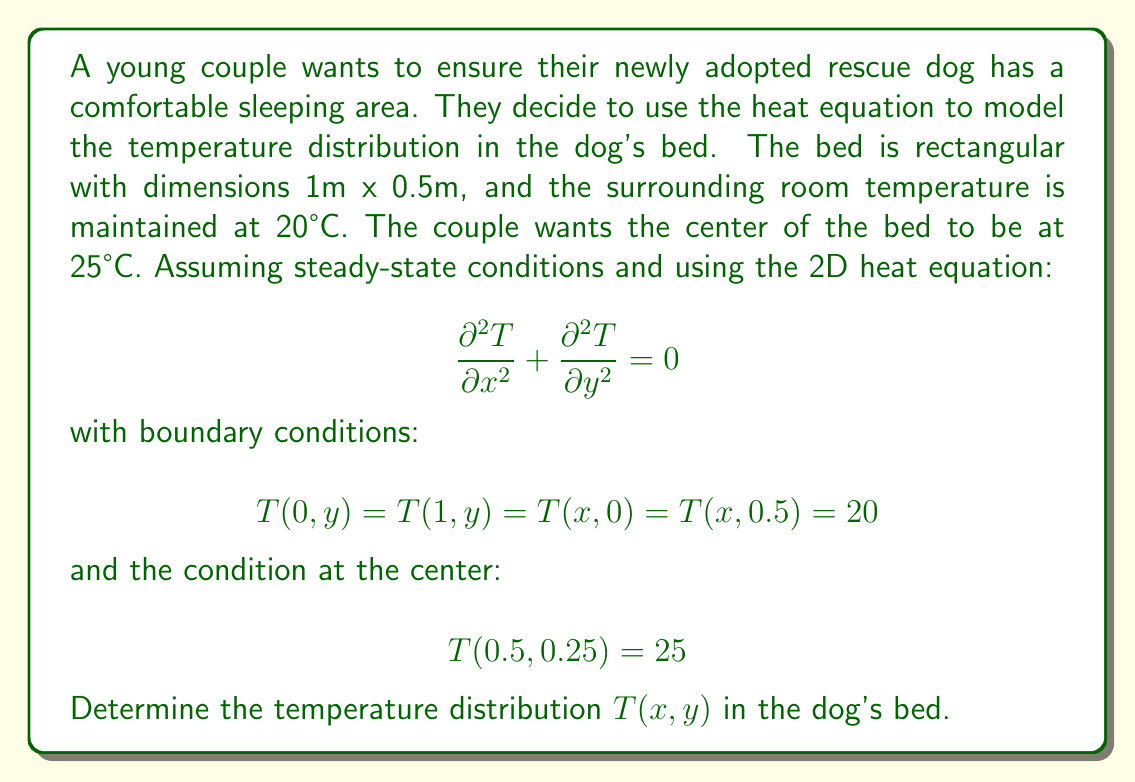Teach me how to tackle this problem. To solve this problem, we'll follow these steps:

1) The general solution for the 2D steady-state heat equation is:

   $$T(x,y) = A + Bx + Cy + \sum_{n=1}^{\infty} (D_n \sinh(n\pi y) + E_n \sinh(n\pi(0.5-y))) \sin(n\pi x)$$

2) Applying the boundary conditions:
   
   $T(0,y) = T(1,y) = 20$ implies $A = 20$ and $B = 0$
   $T(x,0) = T(x,0.5) = 20$ implies $C = 0$ and $D_n = -E_n$

3) Our solution now becomes:

   $$T(x,y) = 20 + \sum_{n=1}^{\infty} D_n (\sinh(n\pi y) - \sinh(n\pi(0.5-y))) \sin(n\pi x)$$

4) To satisfy $T(0.5, 0.25) = 25$, we need:

   $$25 = 20 + \sum_{n=1}^{\infty} D_n (\sinh(0.25n\pi) - \sinh(0.25n\pi)) \sin(0.5n\pi)$$

5) Simplify:

   $$5 = \sum_{n=1,3,5,...}^{\infty} 2D_n \sinh(0.25n\pi) \sin(0.5n\pi)$$

6) We can approximate this by taking only the first term (n=1):

   $$5 \approx 2D_1 \sinh(0.25\pi) \sin(0.5\pi)$$

7) Solve for $D_1$:

   $$D_1 \approx \frac{5}{2 \sinh(0.25\pi) \sin(0.5\pi)} \approx 2.27$$

8) Therefore, our approximate solution is:

   $$T(x,y) \approx 20 + 2.27(\sinh(\pi y) - \sinh(\pi(0.5-y))) \sin(\pi x)$$

This function gives the temperature distribution in the dog's bed, satisfying the given conditions.
Answer: $$T(x,y) \approx 20 + 2.27(\sinh(\pi y) - \sinh(\pi(0.5-y))) \sin(\pi x)$$ 